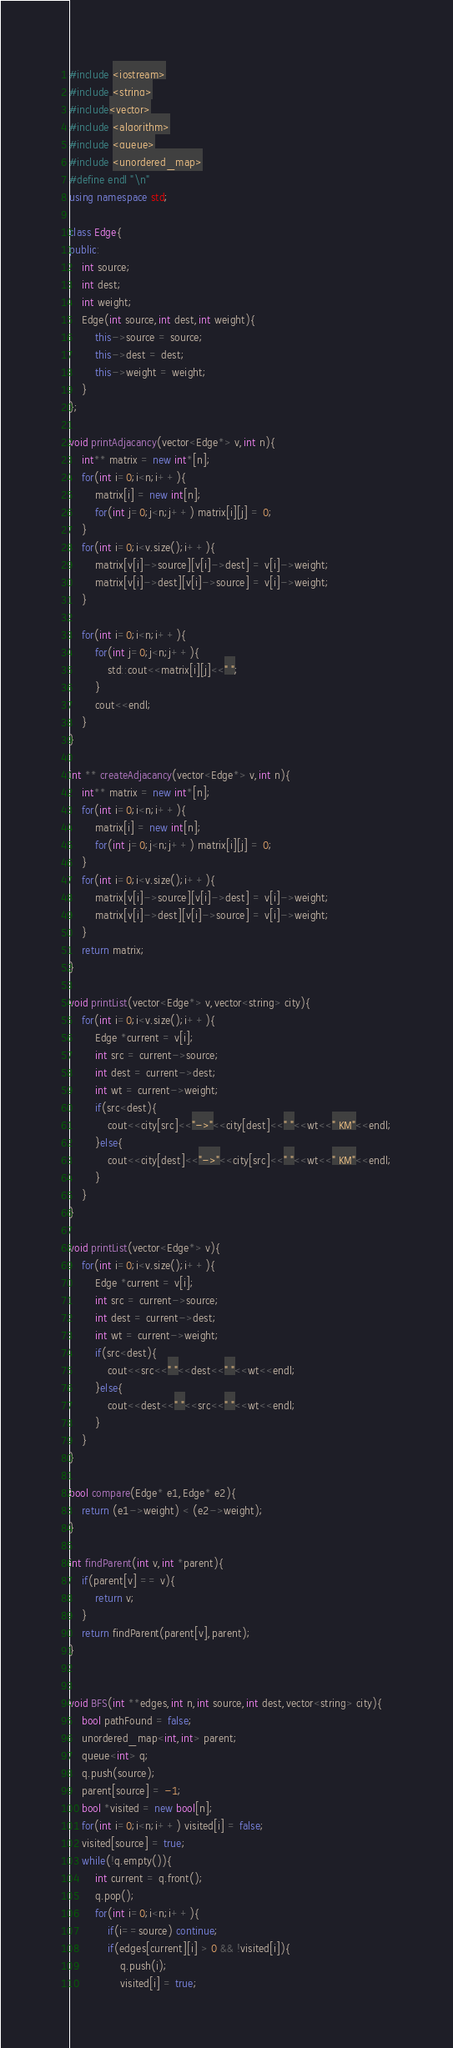Convert code to text. <code><loc_0><loc_0><loc_500><loc_500><_C++_>#include <iostream>
#include <string>
#include<vector>
#include <algorithm>
#include <queue>
#include <unordered_map>
#define endl "\n"
using namespace std;

class Edge{
public:
	int source;
	int dest;
	int weight;
	Edge(int source,int dest,int weight){
		this->source = source;
		this->dest = dest;
		this->weight = weight;
	}
};

void printAdjacancy(vector<Edge*> v,int n){
	int** matrix = new int*[n];
	for(int i=0;i<n;i++){
		matrix[i] = new int[n];
		for(int j=0;j<n;j++) matrix[i][j] = 0;
	}
	for(int i=0;i<v.size();i++){
		matrix[v[i]->source][v[i]->dest] = v[i]->weight;
		matrix[v[i]->dest][v[i]->source] = v[i]->weight;
	}

	for(int i=0;i<n;i++){
		for(int j=0;j<n;j++){
			std::cout<<matrix[i][j]<<" ";
		}
		cout<<endl;
	}
}

int ** createAdjacancy(vector<Edge*> v,int n){
	int** matrix = new int*[n];
	for(int i=0;i<n;i++){
		matrix[i] = new int[n];
		for(int j=0;j<n;j++) matrix[i][j] = 0;
	}
	for(int i=0;i<v.size();i++){
		matrix[v[i]->source][v[i]->dest] = v[i]->weight;
		matrix[v[i]->dest][v[i]->source] = v[i]->weight;
	}
	return matrix;
}

void printList(vector<Edge*> v,vector<string> city){
	for(int i=0;i<v.size();i++){
		Edge *current = v[i];
		int src = current->source;
		int dest = current->dest;
		int wt = current->weight;
		if(src<dest){
			cout<<city[src]<<"->"<<city[dest]<<" "<<wt<<" KM"<<endl;
		}else{
			cout<<city[dest]<<"->"<<city[src]<<" "<<wt<<" KM"<<endl;
		}
	}
}

void printList(vector<Edge*> v){
	for(int i=0;i<v.size();i++){
		Edge *current = v[i];
		int src = current->source;
		int dest = current->dest;
		int wt = current->weight;
		if(src<dest){
			cout<<src<<" "<<dest<<" "<<wt<<endl;
		}else{
			cout<<dest<<" "<<src<<" "<<wt<<endl;
		}
	}
}

bool compare(Edge* e1,Edge* e2){
	return (e1->weight) < (e2->weight);
}

int findParent(int v,int *parent){
	if(parent[v] == v){
		return v;
	}
	return findParent(parent[v],parent);
}


void BFS(int **edges,int n,int source,int dest,vector<string> city){
	bool pathFound = false;
	unordered_map<int,int> parent;
	queue<int> q;
	q.push(source);
	parent[source] = -1;
	bool *visited = new bool[n];
	for(int i=0;i<n;i++) visited[i] = false;
	visited[source] = true;
	while(!q.empty()){
		int current = q.front();
		q.pop();
		for(int i=0;i<n;i++){
			if(i==source) continue;
			if(edges[current][i] > 0 && !visited[i]){
				q.push(i);
				visited[i] = true;</code> 